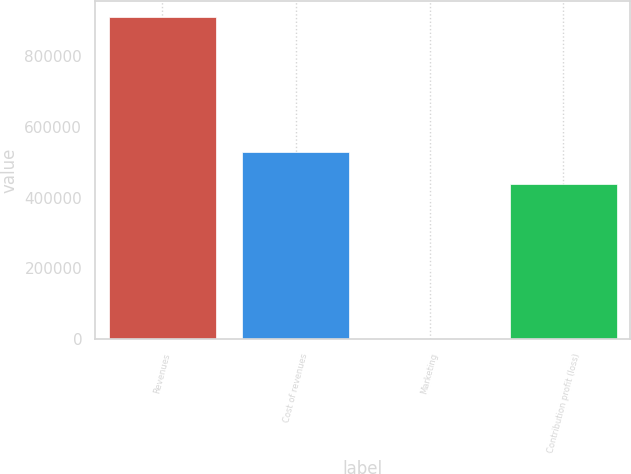Convert chart. <chart><loc_0><loc_0><loc_500><loc_500><bar_chart><fcel>Revenues<fcel>Cost of revenues<fcel>Marketing<fcel>Contribution profit (loss)<nl><fcel>910797<fcel>530032<fcel>292<fcel>438982<nl></chart> 